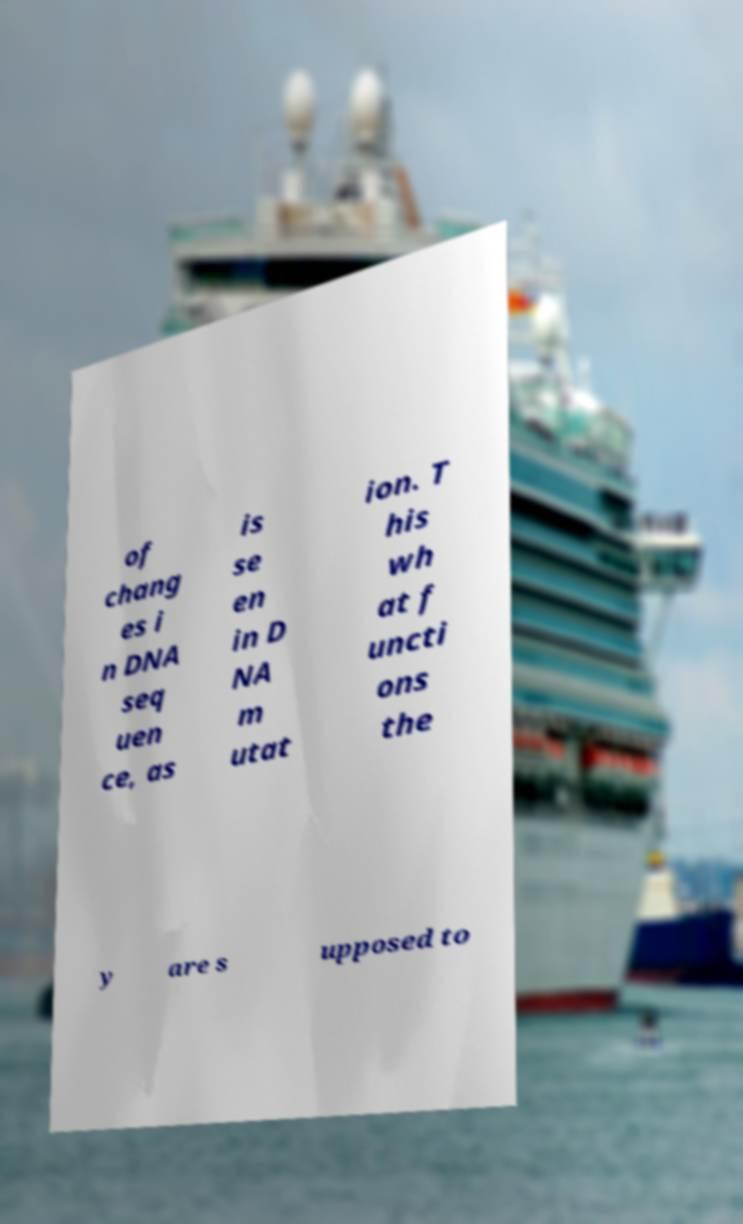Could you extract and type out the text from this image? of chang es i n DNA seq uen ce, as is se en in D NA m utat ion. T his wh at f uncti ons the y are s upposed to 